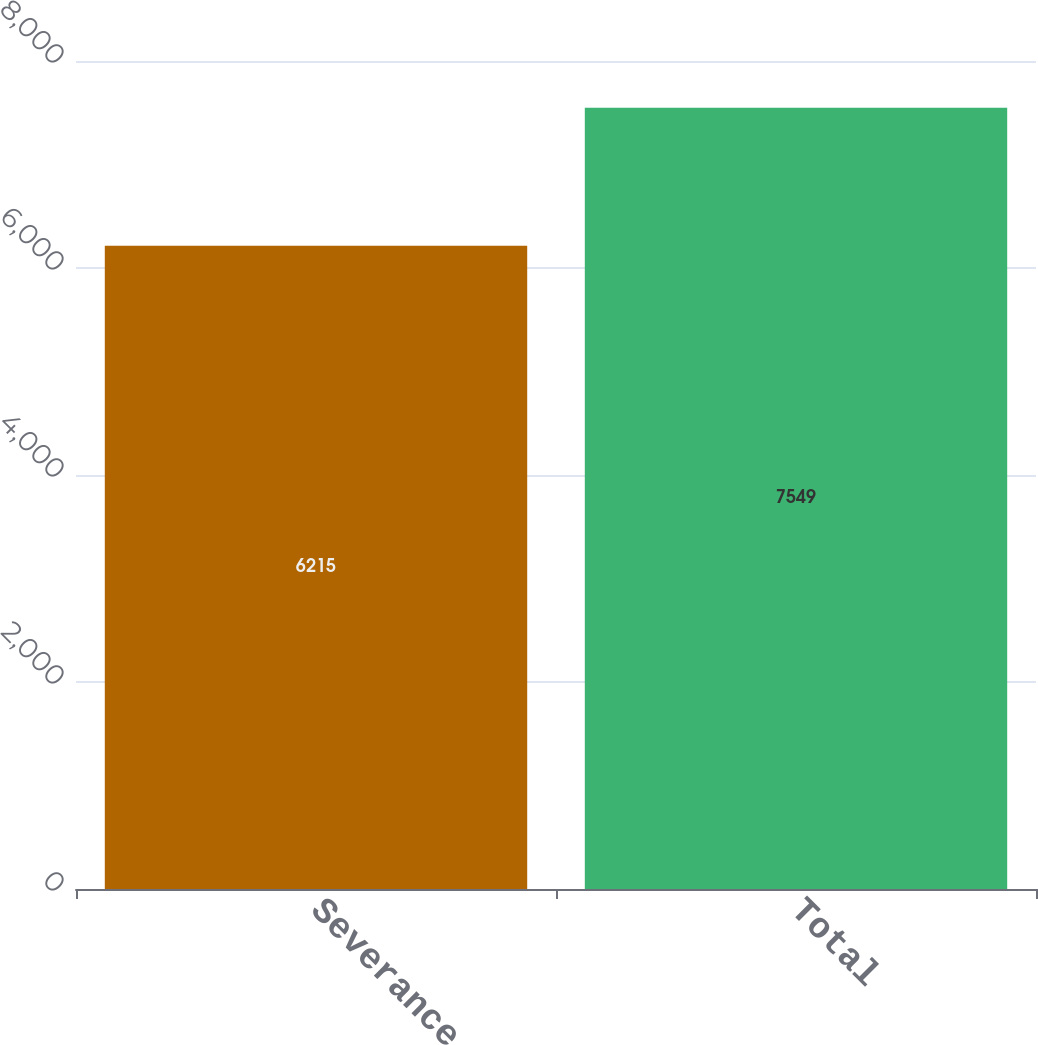Convert chart to OTSL. <chart><loc_0><loc_0><loc_500><loc_500><bar_chart><fcel>Severance<fcel>Total<nl><fcel>6215<fcel>7549<nl></chart> 